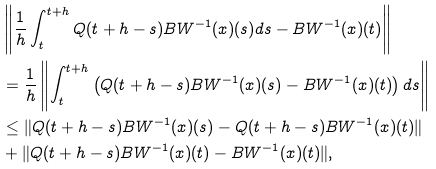Convert formula to latex. <formula><loc_0><loc_0><loc_500><loc_500>& \left \| \frac { 1 } { h } \int _ { t } ^ { t + h } Q ( t + h - s ) B W ^ { - 1 } ( x ) ( s ) d s - B W ^ { - 1 } ( x ) ( t ) \right \| \\ & = \frac { 1 } { h } \left \| \int _ { t } ^ { t + h } \left ( Q ( t + h - s ) B W ^ { - 1 } ( x ) ( s ) - B W ^ { - 1 } ( x ) ( t ) \right ) d s \right \| \\ & \leq \| Q ( t + h - s ) B W ^ { - 1 } ( x ) ( s ) - Q ( t + h - s ) B W ^ { - 1 } ( x ) ( t ) \| \\ & + \| Q ( t + h - s ) B W ^ { - 1 } ( x ) ( t ) - B W ^ { - 1 } ( x ) ( t ) \| ,</formula> 